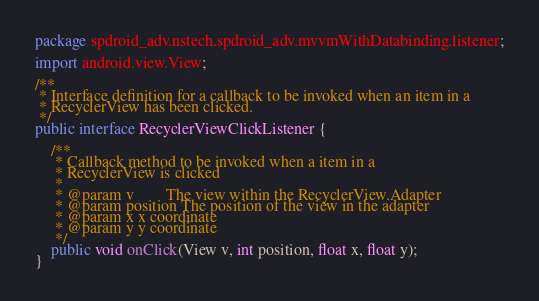<code> <loc_0><loc_0><loc_500><loc_500><_Java_>package spdroid_adv.nstech.spdroid_adv.mvvmWithDatabinding.listener;

import android.view.View;

/**
 * Interface definition for a callback to be invoked when an item in a
 * RecyclerView has been clicked.
 */
public interface RecyclerViewClickListener {

    /**
     * Callback method to be invoked when a item in a
     * RecyclerView is clicked
     *
     * @param v        The view within the RecyclerView.Adapter
     * @param position The position of the view in the adapter
     * @param x x coordinate
     * @param y y coordinate
     */
    public void onClick(View v, int position, float x, float y);
}</code> 